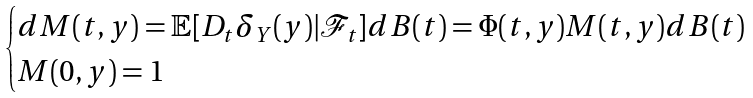Convert formula to latex. <formula><loc_0><loc_0><loc_500><loc_500>\begin{cases} d M ( t , y ) = \mathbb { E } [ D _ { t } \delta _ { Y } ( y ) | \mathcal { F } _ { t } ] d B ( t ) = \Phi ( t , y ) M ( t , y ) d B ( t ) \\ M ( 0 , y ) = 1 \end{cases}</formula> 